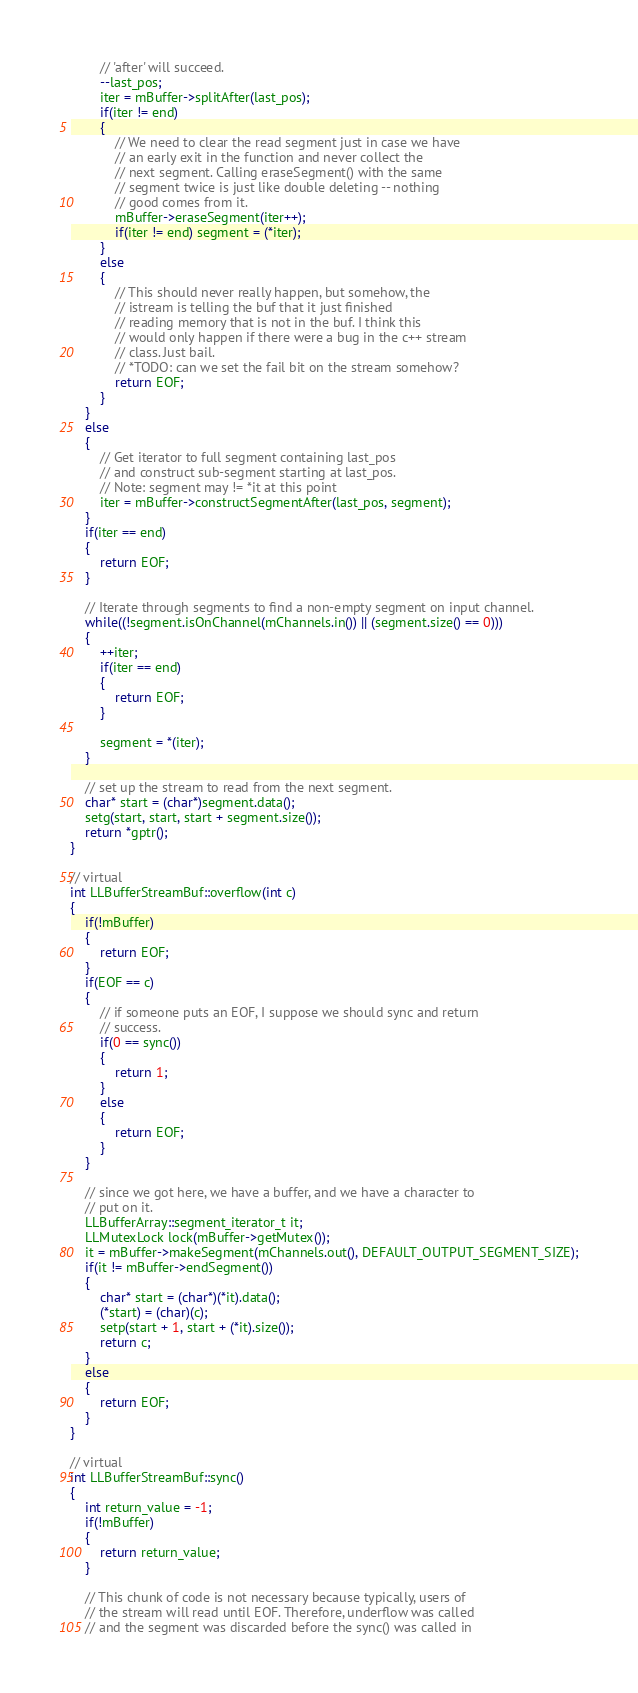Convert code to text. <code><loc_0><loc_0><loc_500><loc_500><_C++_>		// 'after' will succeed.
		--last_pos;
		iter = mBuffer->splitAfter(last_pos);
		if(iter != end)
		{
			// We need to clear the read segment just in case we have
			// an early exit in the function and never collect the
			// next segment. Calling eraseSegment() with the same
			// segment twice is just like double deleting -- nothing
			// good comes from it.
			mBuffer->eraseSegment(iter++);
			if(iter != end) segment = (*iter);
		}
		else
		{
			// This should never really happen, but somehow, the
			// istream is telling the buf that it just finished
			// reading memory that is not in the buf. I think this
			// would only happen if there were a bug in the c++ stream
			// class. Just bail.
			// *TODO: can we set the fail bit on the stream somehow?
			return EOF;
		}
	}
	else
	{
		// Get iterator to full segment containing last_pos
		// and construct sub-segment starting at last_pos.
		// Note: segment may != *it at this point
		iter = mBuffer->constructSegmentAfter(last_pos, segment);
	}
	if(iter == end)
	{
		return EOF;
	}

	// Iterate through segments to find a non-empty segment on input channel.
	while((!segment.isOnChannel(mChannels.in()) || (segment.size() == 0)))
	{
		++iter;
		if(iter == end)
		{
			return EOF;
		}

		segment = *(iter);
	}

	// set up the stream to read from the next segment.
	char* start = (char*)segment.data();
	setg(start, start, start + segment.size());
	return *gptr();
}

// virtual
int LLBufferStreamBuf::overflow(int c)
{
	if(!mBuffer)
	{
		return EOF;
	}
	if(EOF == c)
	{
		// if someone puts an EOF, I suppose we should sync and return
		// success.
		if(0 == sync())
		{
			return 1;
		}
		else
		{
			return EOF;
		}
	}

	// since we got here, we have a buffer, and we have a character to
	// put on it.
	LLBufferArray::segment_iterator_t it;
	LLMutexLock lock(mBuffer->getMutex());
	it = mBuffer->makeSegment(mChannels.out(), DEFAULT_OUTPUT_SEGMENT_SIZE);
	if(it != mBuffer->endSegment())
	{
		char* start = (char*)(*it).data();
		(*start) = (char)(c);
		setp(start + 1, start + (*it).size());
		return c;
	}
	else
	{
		return EOF;
	}
}

// virtual
int LLBufferStreamBuf::sync()
{
	int return_value = -1;
	if(!mBuffer)
	{
		return return_value;
	}

	// This chunk of code is not necessary because typically, users of
	// the stream will read until EOF. Therefore, underflow was called
	// and the segment was discarded before the sync() was called in</code> 